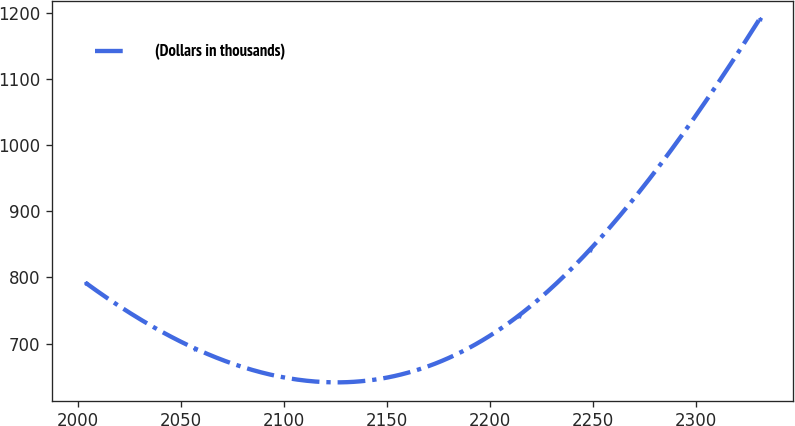Convert chart. <chart><loc_0><loc_0><loc_500><loc_500><line_chart><ecel><fcel>(Dollars in thousands)<nl><fcel>2003.87<fcel>791.92<nl><fcel>2057.21<fcel>692.18<nl><fcel>2213.96<fcel>742.05<nl><fcel>2248.51<fcel>841.79<nl><fcel>2330.9<fcel>1190.86<nl></chart> 